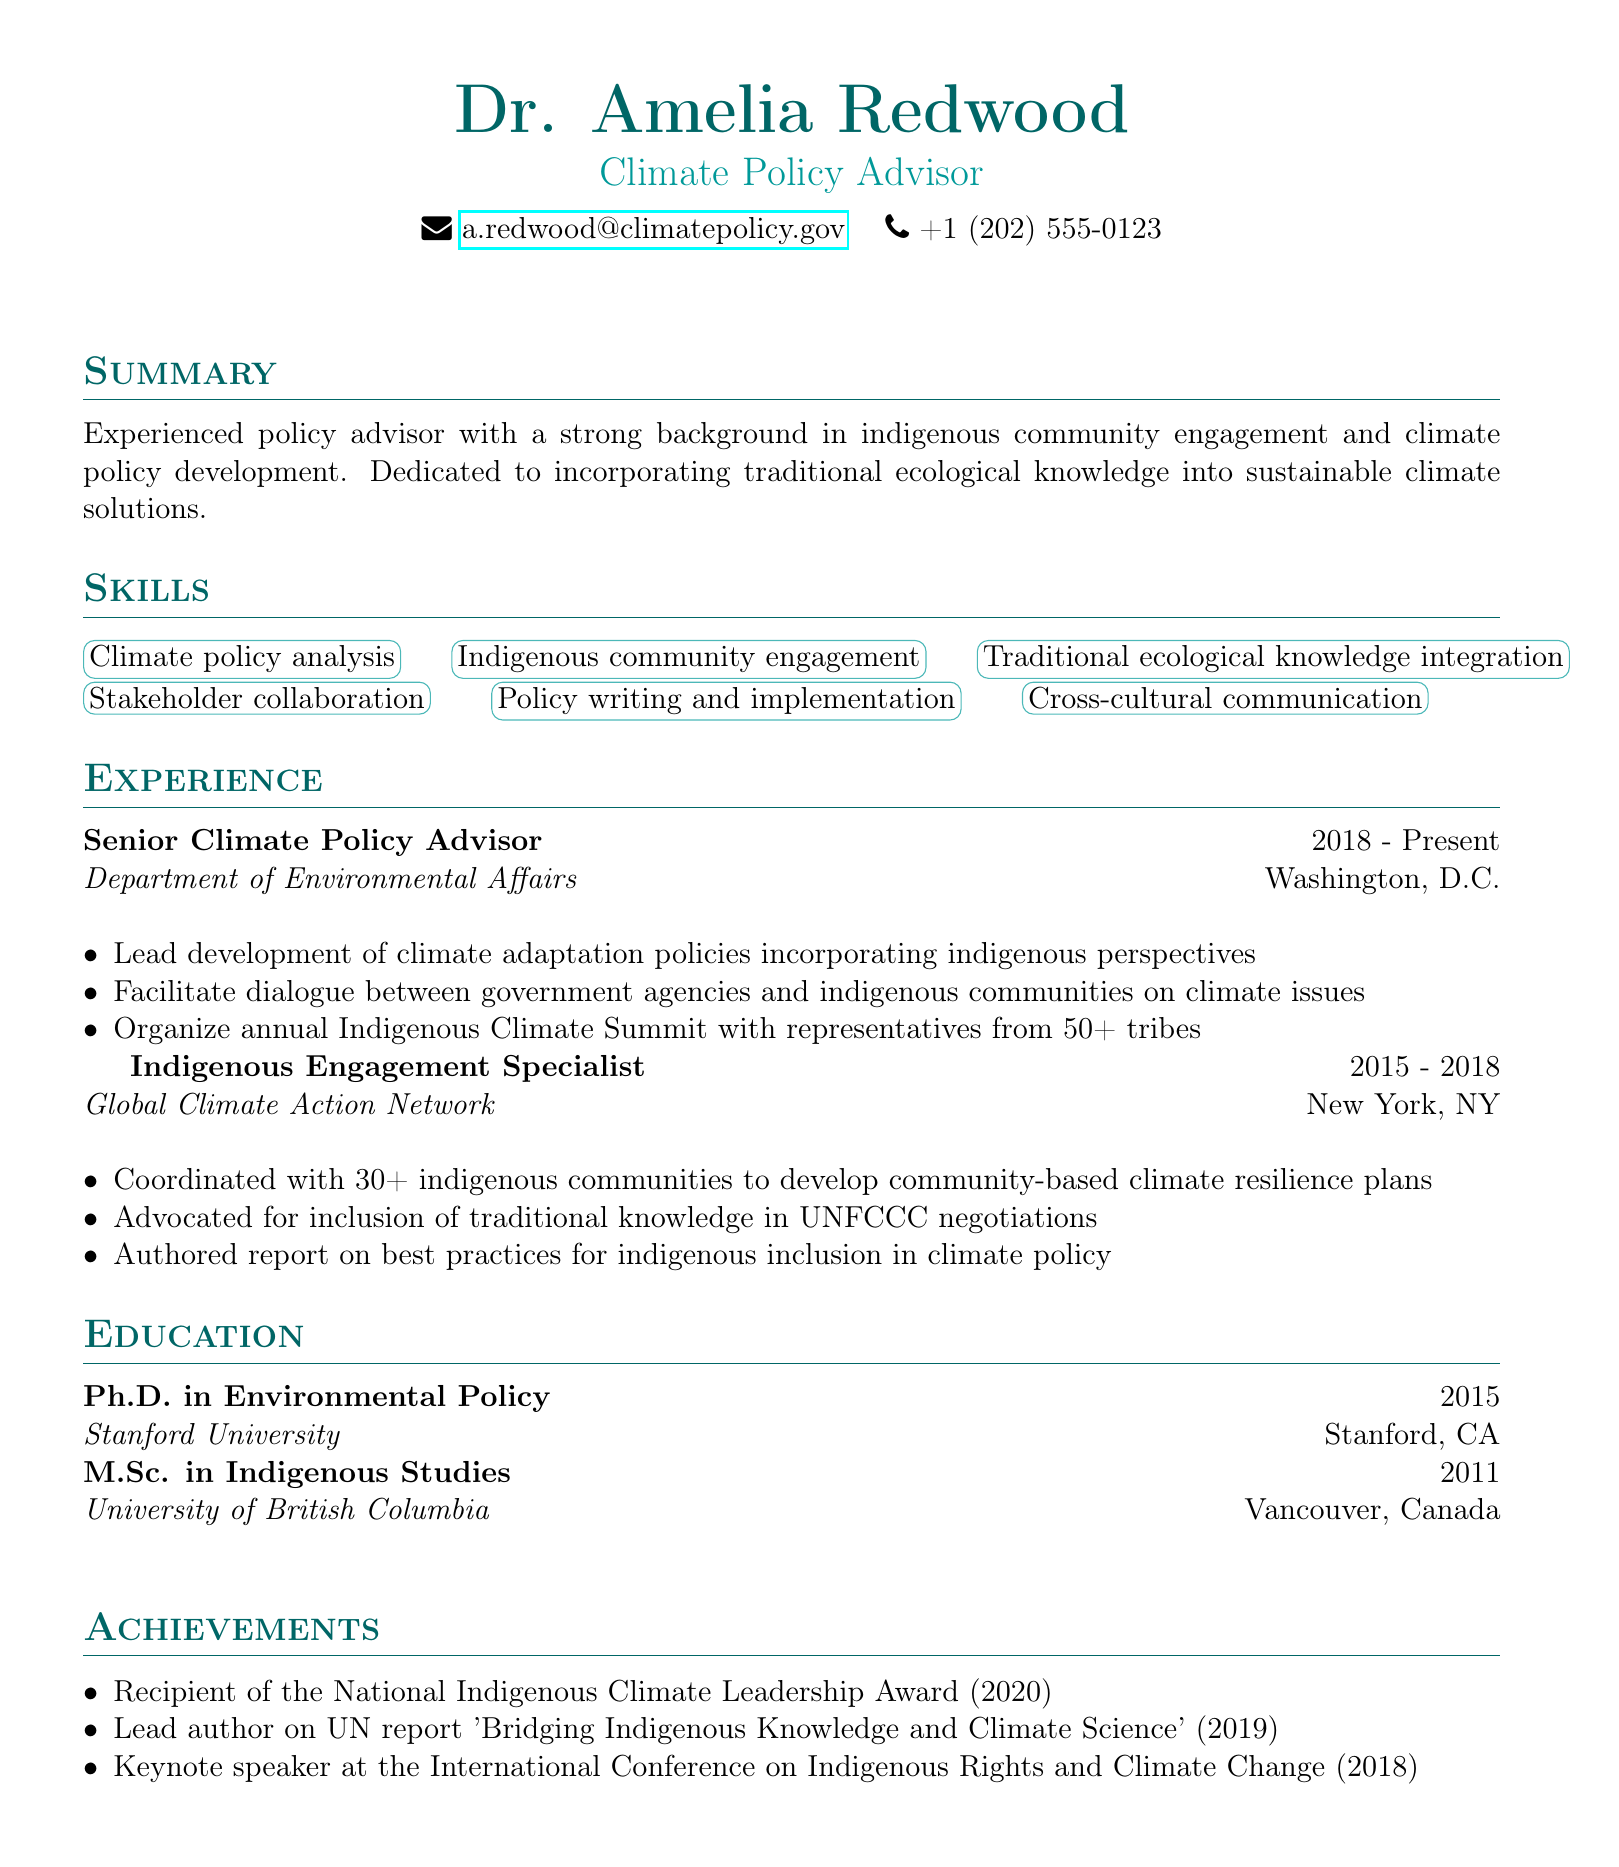What is Dr. Amelia Redwood's title? The title listed in the document is the professional position held by Dr. Amelia Redwood.
Answer: Climate Policy Advisor What is the email address provided in the resume? The email address is the method of contact for Dr. Amelia Redwood listed in the personal info section.
Answer: a.redwood@climatepolicy.gov How many years did Dr. Redwood work as an Indigenous Engagement Specialist? The duration listed for this position provides the timeframe of employment in years.
Answer: 3 years What award did Dr. Redwood receive in 2020? The achievement section details significant recognitions received by Dr. Amelia Redwood during their career.
Answer: National Indigenous Climate Leadership Award How many indigenous communities did Dr. Redwood coordinate with at Global Climate Action Network? This information is found in the responsibilities of the Indigenous Engagement Specialist position, indicating the scale of her engagement.
Answer: 30+ Which university did Dr. Redwood attend for her Ph.D.? The education section specifies where she completed her doctoral studies, which is relevant information about her qualifications.
Answer: Stanford University What is one of the responsibilities of a Senior Climate Policy Advisor? This question requires synthesis of the listed duties in her current position, highlighting her focus area.
Answer: Lead development of climate adaptation policies incorporating indigenous perspectives Which conference did Dr. Redwood give a keynote speech at? This question asks for a specific event related to her achievements that showcases her expertise and recognition in the field.
Answer: International Conference on Indigenous Rights and Climate Change 